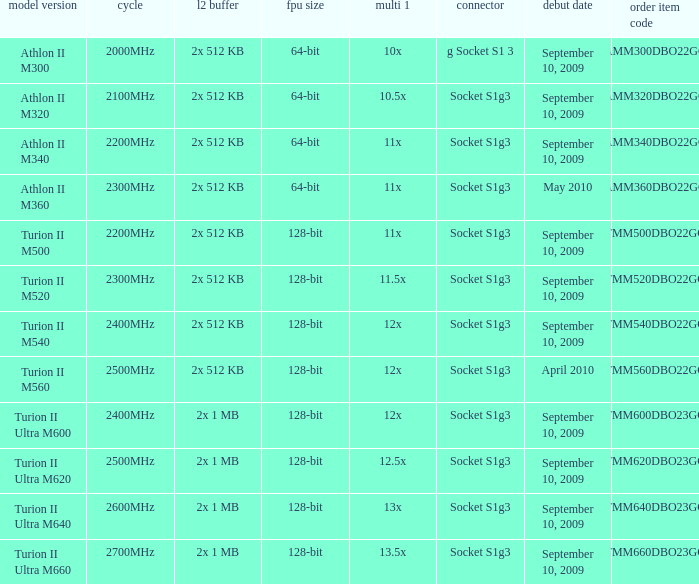What is the L2 cache with a release date on September 10, 2009, a 128-bit FPU width, and a 12x multi 1? 2x 512 KB, 2x 1 MB. 